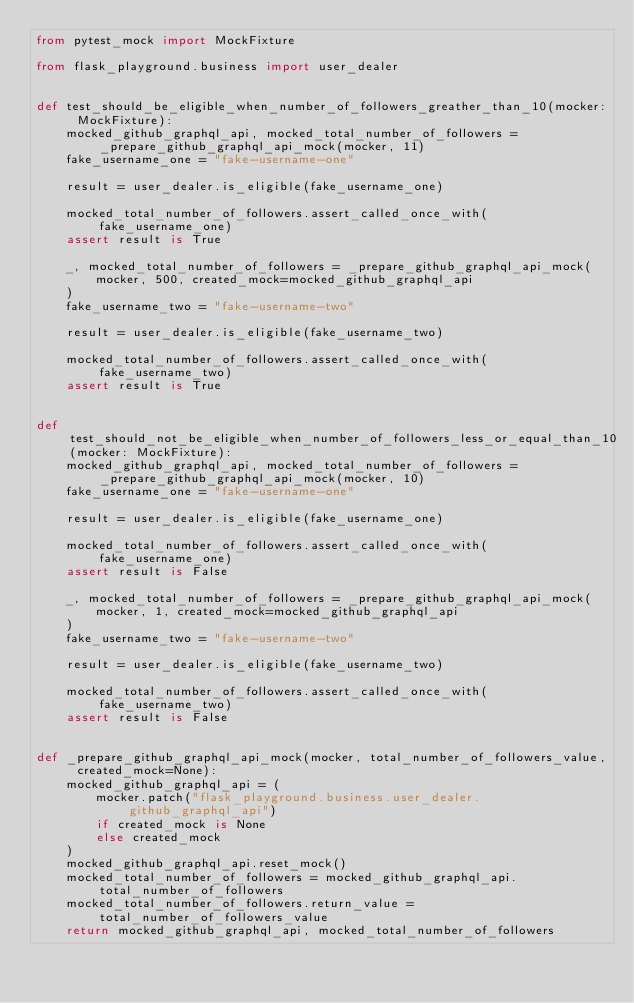<code> <loc_0><loc_0><loc_500><loc_500><_Python_>from pytest_mock import MockFixture

from flask_playground.business import user_dealer


def test_should_be_eligible_when_number_of_followers_greather_than_10(mocker: MockFixture):
    mocked_github_graphql_api, mocked_total_number_of_followers = _prepare_github_graphql_api_mock(mocker, 11)
    fake_username_one = "fake-username-one"

    result = user_dealer.is_eligible(fake_username_one)

    mocked_total_number_of_followers.assert_called_once_with(fake_username_one)
    assert result is True

    _, mocked_total_number_of_followers = _prepare_github_graphql_api_mock(
        mocker, 500, created_mock=mocked_github_graphql_api
    )
    fake_username_two = "fake-username-two"

    result = user_dealer.is_eligible(fake_username_two)

    mocked_total_number_of_followers.assert_called_once_with(fake_username_two)
    assert result is True


def test_should_not_be_eligible_when_number_of_followers_less_or_equal_than_10(mocker: MockFixture):
    mocked_github_graphql_api, mocked_total_number_of_followers = _prepare_github_graphql_api_mock(mocker, 10)
    fake_username_one = "fake-username-one"

    result = user_dealer.is_eligible(fake_username_one)

    mocked_total_number_of_followers.assert_called_once_with(fake_username_one)
    assert result is False

    _, mocked_total_number_of_followers = _prepare_github_graphql_api_mock(
        mocker, 1, created_mock=mocked_github_graphql_api
    )
    fake_username_two = "fake-username-two"

    result = user_dealer.is_eligible(fake_username_two)

    mocked_total_number_of_followers.assert_called_once_with(fake_username_two)
    assert result is False


def _prepare_github_graphql_api_mock(mocker, total_number_of_followers_value, created_mock=None):
    mocked_github_graphql_api = (
        mocker.patch("flask_playground.business.user_dealer.github_graphql_api")
        if created_mock is None
        else created_mock
    )
    mocked_github_graphql_api.reset_mock()
    mocked_total_number_of_followers = mocked_github_graphql_api.total_number_of_followers
    mocked_total_number_of_followers.return_value = total_number_of_followers_value
    return mocked_github_graphql_api, mocked_total_number_of_followers
</code> 